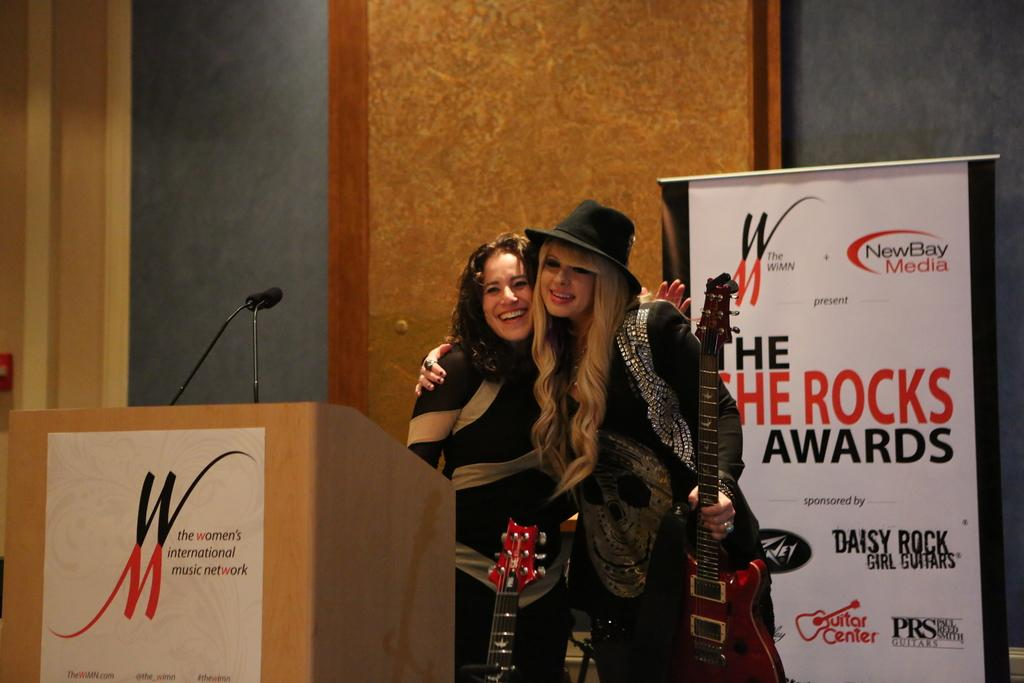What can be seen in the background of the image? There is a wall in the image. What are the two people doing in the image? The two people are standing on a stage. What is hanging on the wall in the image? There is a poster in the image. What is used for amplifying sound in the image? There is a microphone (mike) in the image. What type of vegetable is being used as a prop on the stage? There is no vegetable present in the image; the two people are standing on a stage with a poster and a microphone. What tool is being used to tighten the screws on the microphone stand? There is no wrench present in the image, and the microphone stand is not being adjusted. 